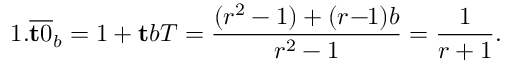Convert formula to latex. <formula><loc_0><loc_0><loc_500><loc_500>1 . { \overline { t 0 } } _ { b } = 1 + t b T = { \frac { ( r ^ { 2 } - 1 ) + ( r \, - \, 1 ) b } { r ^ { 2 } - 1 } } = { \frac { 1 } { r + 1 } } .</formula> 